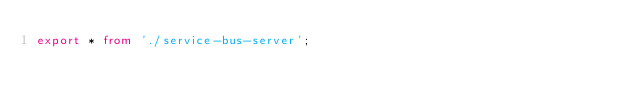<code> <loc_0><loc_0><loc_500><loc_500><_TypeScript_>export * from './service-bus-server';
</code> 